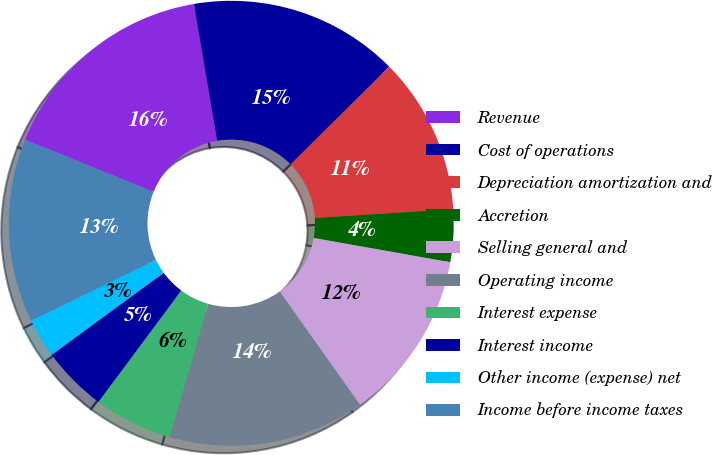<chart> <loc_0><loc_0><loc_500><loc_500><pie_chart><fcel>Revenue<fcel>Cost of operations<fcel>Depreciation amortization and<fcel>Accretion<fcel>Selling general and<fcel>Operating income<fcel>Interest expense<fcel>Interest income<fcel>Other income (expense) net<fcel>Income before income taxes<nl><fcel>16.19%<fcel>15.24%<fcel>11.43%<fcel>3.81%<fcel>12.38%<fcel>14.29%<fcel>5.71%<fcel>4.76%<fcel>2.86%<fcel>13.33%<nl></chart> 